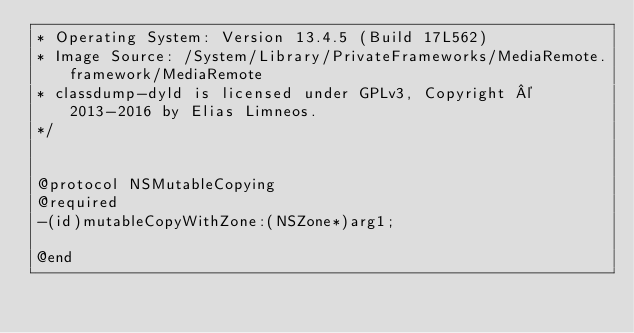<code> <loc_0><loc_0><loc_500><loc_500><_C_>* Operating System: Version 13.4.5 (Build 17L562)
* Image Source: /System/Library/PrivateFrameworks/MediaRemote.framework/MediaRemote
* classdump-dyld is licensed under GPLv3, Copyright © 2013-2016 by Elias Limneos.
*/


@protocol NSMutableCopying
@required
-(id)mutableCopyWithZone:(NSZone*)arg1;

@end

</code> 